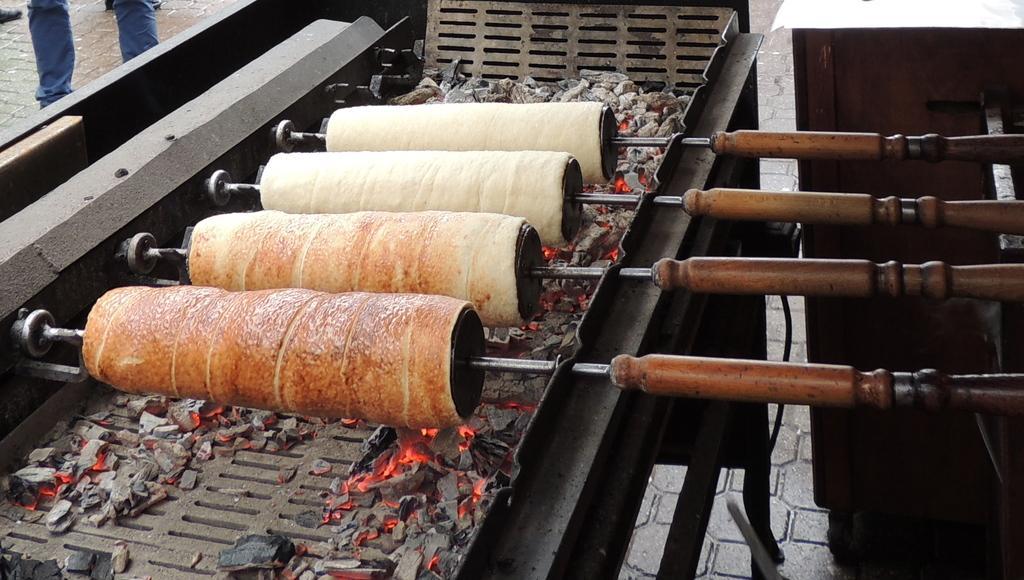Please provide a concise description of this image. In this picture we can see coals on a machine and food items are rolled to the objects. 